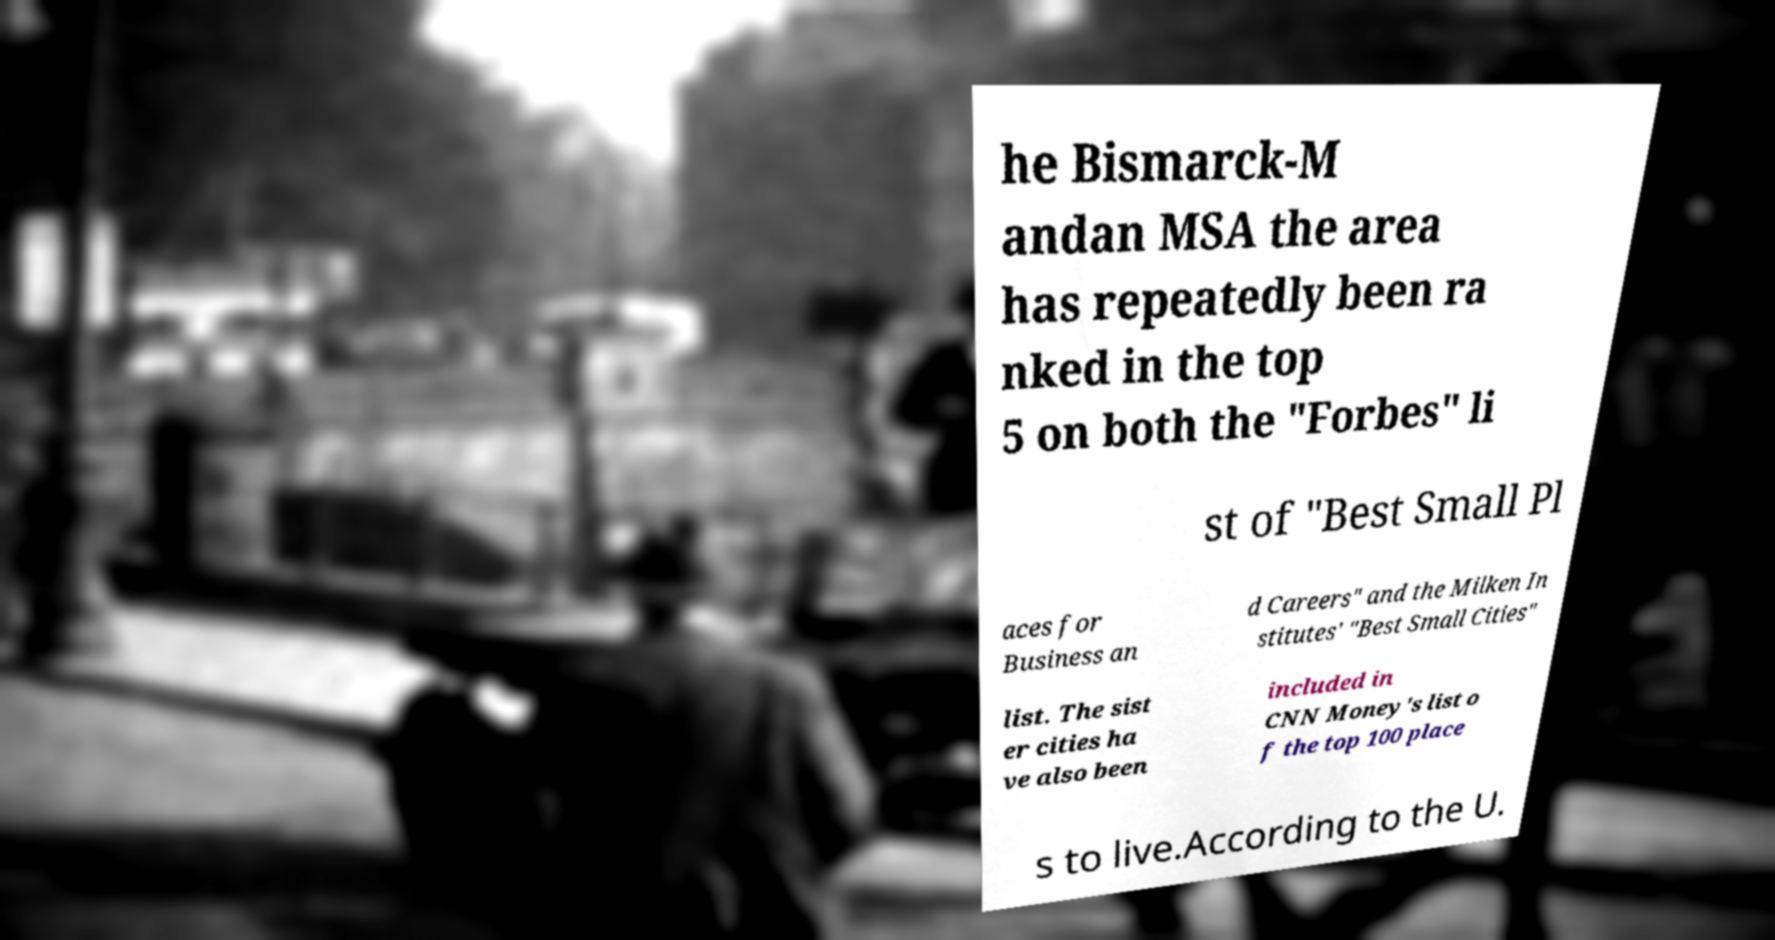Could you extract and type out the text from this image? he Bismarck-M andan MSA the area has repeatedly been ra nked in the top 5 on both the "Forbes" li st of "Best Small Pl aces for Business an d Careers" and the Milken In stitutes' "Best Small Cities" list. The sist er cities ha ve also been included in CNN Money's list o f the top 100 place s to live.According to the U. 